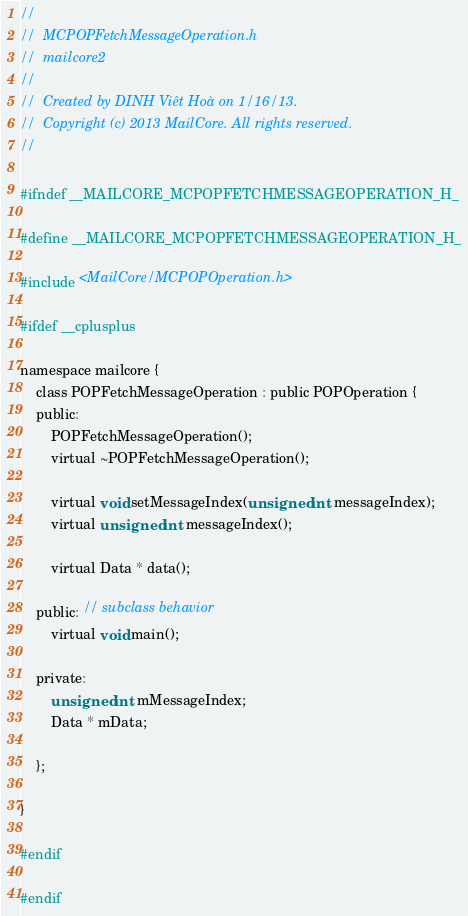Convert code to text. <code><loc_0><loc_0><loc_500><loc_500><_C_>//
//  MCPOPFetchMessageOperation.h
//  mailcore2
//
//  Created by DINH Viêt Hoà on 1/16/13.
//  Copyright (c) 2013 MailCore. All rights reserved.
//

#ifndef __MAILCORE_MCPOPFETCHMESSAGEOPERATION_H_

#define __MAILCORE_MCPOPFETCHMESSAGEOPERATION_H_

#include <MailCore/MCPOPOperation.h>

#ifdef __cplusplus

namespace mailcore {
    class POPFetchMessageOperation : public POPOperation {
    public:
        POPFetchMessageOperation();
        virtual ~POPFetchMessageOperation();
        
        virtual void setMessageIndex(unsigned int messageIndex);
        virtual unsigned int messageIndex();
        
        virtual Data * data();
        
    public: // subclass behavior
        virtual void main();
        
    private:
        unsigned int mMessageIndex;
        Data * mData;
        
    };
    
}

#endif

#endif
</code> 